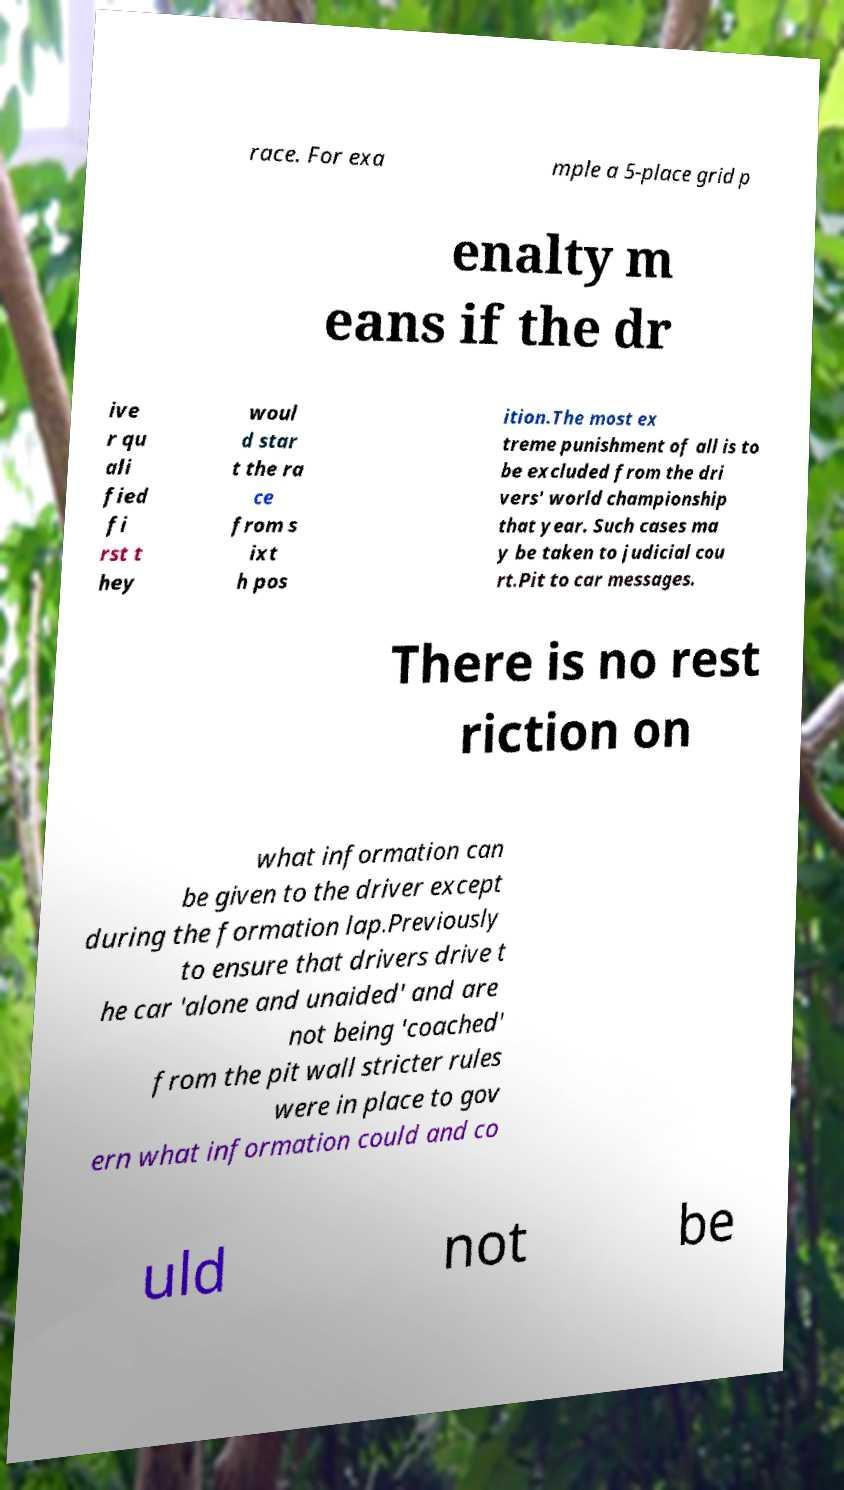For documentation purposes, I need the text within this image transcribed. Could you provide that? race. For exa mple a 5-place grid p enalty m eans if the dr ive r qu ali fied fi rst t hey woul d star t the ra ce from s ixt h pos ition.The most ex treme punishment of all is to be excluded from the dri vers' world championship that year. Such cases ma y be taken to judicial cou rt.Pit to car messages. There is no rest riction on what information can be given to the driver except during the formation lap.Previously to ensure that drivers drive t he car 'alone and unaided' and are not being 'coached' from the pit wall stricter rules were in place to gov ern what information could and co uld not be 